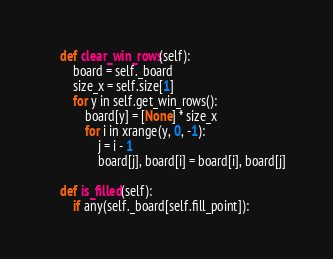<code> <loc_0><loc_0><loc_500><loc_500><_Python_>
    def clear_win_rows(self):
        board = self._board
        size_x = self.size[1]
        for y in self.get_win_rows():
            board[y] = [None] * size_x
            for i in xrange(y, 0, -1):
                j = i - 1
                board[j], board[i] = board[i], board[j]

    def is_filled(self):
        if any(self._board[self.fill_point]):</code> 